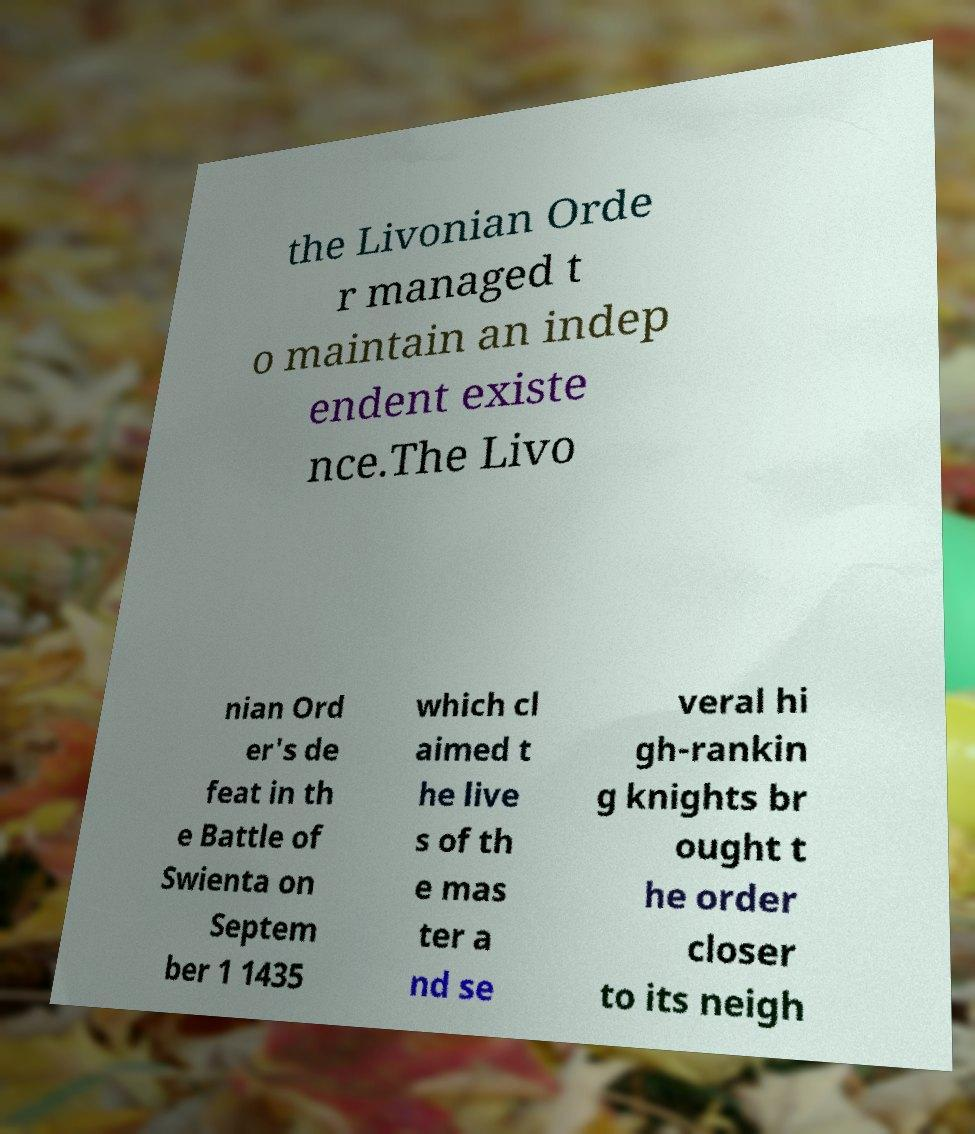For documentation purposes, I need the text within this image transcribed. Could you provide that? the Livonian Orde r managed t o maintain an indep endent existe nce.The Livo nian Ord er's de feat in th e Battle of Swienta on Septem ber 1 1435 which cl aimed t he live s of th e mas ter a nd se veral hi gh-rankin g knights br ought t he order closer to its neigh 